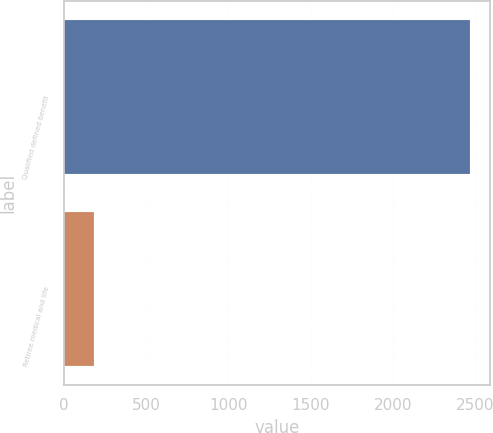<chart> <loc_0><loc_0><loc_500><loc_500><bar_chart><fcel>Qualified defined benefit<fcel>Retiree medical and life<nl><fcel>2470<fcel>180<nl></chart> 